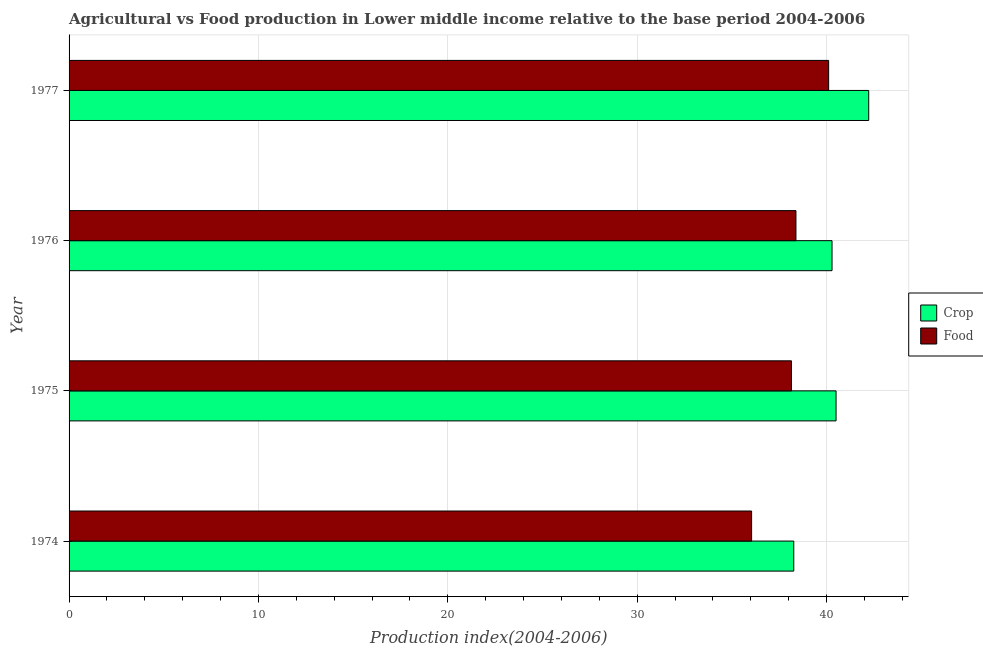How many groups of bars are there?
Give a very brief answer. 4. Are the number of bars on each tick of the Y-axis equal?
Ensure brevity in your answer.  Yes. How many bars are there on the 1st tick from the top?
Keep it short and to the point. 2. How many bars are there on the 1st tick from the bottom?
Keep it short and to the point. 2. What is the label of the 4th group of bars from the top?
Offer a terse response. 1974. In how many cases, is the number of bars for a given year not equal to the number of legend labels?
Offer a very short reply. 0. What is the crop production index in 1977?
Give a very brief answer. 42.22. Across all years, what is the maximum food production index?
Offer a terse response. 40.11. Across all years, what is the minimum food production index?
Ensure brevity in your answer.  36.04. In which year was the food production index maximum?
Offer a terse response. 1977. In which year was the food production index minimum?
Your response must be concise. 1974. What is the total crop production index in the graph?
Your answer should be very brief. 161.27. What is the difference between the crop production index in 1974 and that in 1975?
Offer a terse response. -2.23. What is the difference between the food production index in 1974 and the crop production index in 1977?
Provide a short and direct response. -6.18. What is the average crop production index per year?
Offer a terse response. 40.32. In the year 1974, what is the difference between the crop production index and food production index?
Your answer should be compact. 2.23. Is the food production index in 1974 less than that in 1975?
Provide a short and direct response. Yes. Is the difference between the crop production index in 1974 and 1976 greater than the difference between the food production index in 1974 and 1976?
Your response must be concise. Yes. What is the difference between the highest and the second highest food production index?
Give a very brief answer. 1.73. What is the difference between the highest and the lowest food production index?
Keep it short and to the point. 4.07. In how many years, is the food production index greater than the average food production index taken over all years?
Offer a terse response. 2. Is the sum of the crop production index in 1975 and 1976 greater than the maximum food production index across all years?
Your answer should be compact. Yes. What does the 1st bar from the top in 1977 represents?
Your answer should be very brief. Food. What does the 2nd bar from the bottom in 1974 represents?
Make the answer very short. Food. How many bars are there?
Provide a succinct answer. 8. Does the graph contain any zero values?
Offer a terse response. No. Does the graph contain grids?
Ensure brevity in your answer.  Yes. Where does the legend appear in the graph?
Provide a succinct answer. Center right. How are the legend labels stacked?
Your response must be concise. Vertical. What is the title of the graph?
Your response must be concise. Agricultural vs Food production in Lower middle income relative to the base period 2004-2006. What is the label or title of the X-axis?
Make the answer very short. Production index(2004-2006). What is the label or title of the Y-axis?
Provide a short and direct response. Year. What is the Production index(2004-2006) of Crop in 1974?
Provide a short and direct response. 38.27. What is the Production index(2004-2006) in Food in 1974?
Provide a succinct answer. 36.04. What is the Production index(2004-2006) in Crop in 1975?
Your answer should be very brief. 40.5. What is the Production index(2004-2006) in Food in 1975?
Your answer should be compact. 38.14. What is the Production index(2004-2006) of Crop in 1976?
Your response must be concise. 40.29. What is the Production index(2004-2006) in Food in 1976?
Your response must be concise. 38.38. What is the Production index(2004-2006) of Crop in 1977?
Ensure brevity in your answer.  42.22. What is the Production index(2004-2006) in Food in 1977?
Your answer should be compact. 40.11. Across all years, what is the maximum Production index(2004-2006) of Crop?
Offer a terse response. 42.22. Across all years, what is the maximum Production index(2004-2006) of Food?
Ensure brevity in your answer.  40.11. Across all years, what is the minimum Production index(2004-2006) of Crop?
Keep it short and to the point. 38.27. Across all years, what is the minimum Production index(2004-2006) of Food?
Your answer should be compact. 36.04. What is the total Production index(2004-2006) in Crop in the graph?
Keep it short and to the point. 161.27. What is the total Production index(2004-2006) of Food in the graph?
Give a very brief answer. 152.67. What is the difference between the Production index(2004-2006) of Crop in 1974 and that in 1975?
Provide a succinct answer. -2.23. What is the difference between the Production index(2004-2006) in Food in 1974 and that in 1975?
Your response must be concise. -2.1. What is the difference between the Production index(2004-2006) of Crop in 1974 and that in 1976?
Ensure brevity in your answer.  -2.02. What is the difference between the Production index(2004-2006) of Food in 1974 and that in 1976?
Ensure brevity in your answer.  -2.34. What is the difference between the Production index(2004-2006) of Crop in 1974 and that in 1977?
Make the answer very short. -3.96. What is the difference between the Production index(2004-2006) of Food in 1974 and that in 1977?
Provide a short and direct response. -4.07. What is the difference between the Production index(2004-2006) of Crop in 1975 and that in 1976?
Provide a succinct answer. 0.21. What is the difference between the Production index(2004-2006) in Food in 1975 and that in 1976?
Make the answer very short. -0.24. What is the difference between the Production index(2004-2006) in Crop in 1975 and that in 1977?
Your response must be concise. -1.72. What is the difference between the Production index(2004-2006) of Food in 1975 and that in 1977?
Provide a short and direct response. -1.96. What is the difference between the Production index(2004-2006) of Crop in 1976 and that in 1977?
Provide a succinct answer. -1.94. What is the difference between the Production index(2004-2006) of Food in 1976 and that in 1977?
Give a very brief answer. -1.73. What is the difference between the Production index(2004-2006) of Crop in 1974 and the Production index(2004-2006) of Food in 1975?
Provide a short and direct response. 0.12. What is the difference between the Production index(2004-2006) in Crop in 1974 and the Production index(2004-2006) in Food in 1976?
Your answer should be compact. -0.12. What is the difference between the Production index(2004-2006) of Crop in 1974 and the Production index(2004-2006) of Food in 1977?
Offer a very short reply. -1.84. What is the difference between the Production index(2004-2006) of Crop in 1975 and the Production index(2004-2006) of Food in 1976?
Provide a short and direct response. 2.12. What is the difference between the Production index(2004-2006) in Crop in 1975 and the Production index(2004-2006) in Food in 1977?
Keep it short and to the point. 0.39. What is the difference between the Production index(2004-2006) in Crop in 1976 and the Production index(2004-2006) in Food in 1977?
Ensure brevity in your answer.  0.18. What is the average Production index(2004-2006) of Crop per year?
Keep it short and to the point. 40.32. What is the average Production index(2004-2006) of Food per year?
Make the answer very short. 38.17. In the year 1974, what is the difference between the Production index(2004-2006) of Crop and Production index(2004-2006) of Food?
Provide a succinct answer. 2.23. In the year 1975, what is the difference between the Production index(2004-2006) in Crop and Production index(2004-2006) in Food?
Provide a short and direct response. 2.35. In the year 1976, what is the difference between the Production index(2004-2006) in Crop and Production index(2004-2006) in Food?
Offer a terse response. 1.91. In the year 1977, what is the difference between the Production index(2004-2006) in Crop and Production index(2004-2006) in Food?
Keep it short and to the point. 2.12. What is the ratio of the Production index(2004-2006) of Crop in 1974 to that in 1975?
Keep it short and to the point. 0.94. What is the ratio of the Production index(2004-2006) of Food in 1974 to that in 1975?
Offer a terse response. 0.94. What is the ratio of the Production index(2004-2006) of Crop in 1974 to that in 1976?
Keep it short and to the point. 0.95. What is the ratio of the Production index(2004-2006) in Food in 1974 to that in 1976?
Give a very brief answer. 0.94. What is the ratio of the Production index(2004-2006) of Crop in 1974 to that in 1977?
Offer a terse response. 0.91. What is the ratio of the Production index(2004-2006) of Food in 1974 to that in 1977?
Ensure brevity in your answer.  0.9. What is the ratio of the Production index(2004-2006) of Crop in 1975 to that in 1977?
Provide a succinct answer. 0.96. What is the ratio of the Production index(2004-2006) of Food in 1975 to that in 1977?
Provide a short and direct response. 0.95. What is the ratio of the Production index(2004-2006) of Crop in 1976 to that in 1977?
Your response must be concise. 0.95. What is the ratio of the Production index(2004-2006) of Food in 1976 to that in 1977?
Make the answer very short. 0.96. What is the difference between the highest and the second highest Production index(2004-2006) of Crop?
Keep it short and to the point. 1.72. What is the difference between the highest and the second highest Production index(2004-2006) of Food?
Offer a terse response. 1.73. What is the difference between the highest and the lowest Production index(2004-2006) of Crop?
Your answer should be very brief. 3.96. What is the difference between the highest and the lowest Production index(2004-2006) of Food?
Make the answer very short. 4.07. 